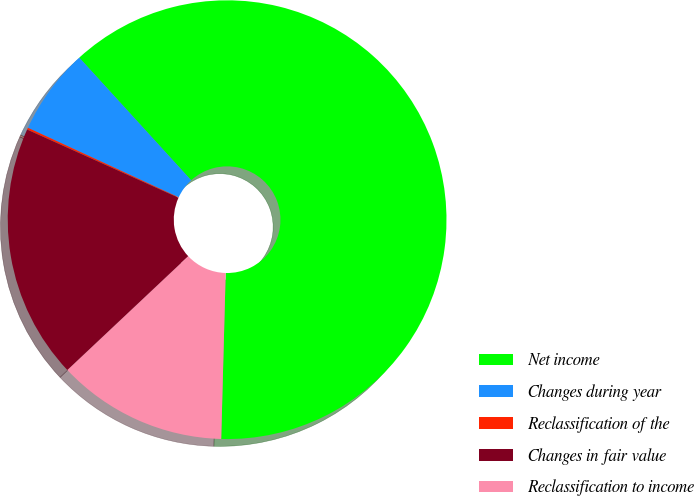Convert chart. <chart><loc_0><loc_0><loc_500><loc_500><pie_chart><fcel>Net income<fcel>Changes during year<fcel>Reclassification of the<fcel>Changes in fair value<fcel>Reclassification to income<nl><fcel>62.2%<fcel>6.35%<fcel>0.14%<fcel>18.76%<fcel>12.55%<nl></chart> 